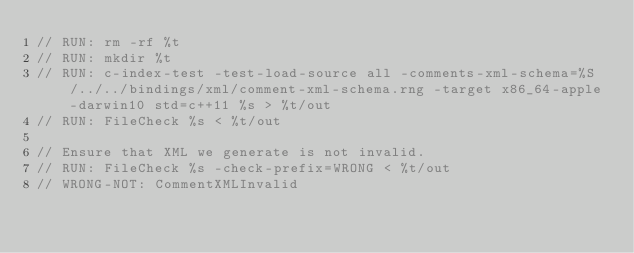<code> <loc_0><loc_0><loc_500><loc_500><_C++_>// RUN: rm -rf %t
// RUN: mkdir %t
// RUN: c-index-test -test-load-source all -comments-xml-schema=%S/../../bindings/xml/comment-xml-schema.rng -target x86_64-apple-darwin10 std=c++11 %s > %t/out
// RUN: FileCheck %s < %t/out

// Ensure that XML we generate is not invalid.
// RUN: FileCheck %s -check-prefix=WRONG < %t/out
// WRONG-NOT: CommentXMLInvalid</code> 